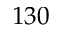<formula> <loc_0><loc_0><loc_500><loc_500>1 3 0</formula> 